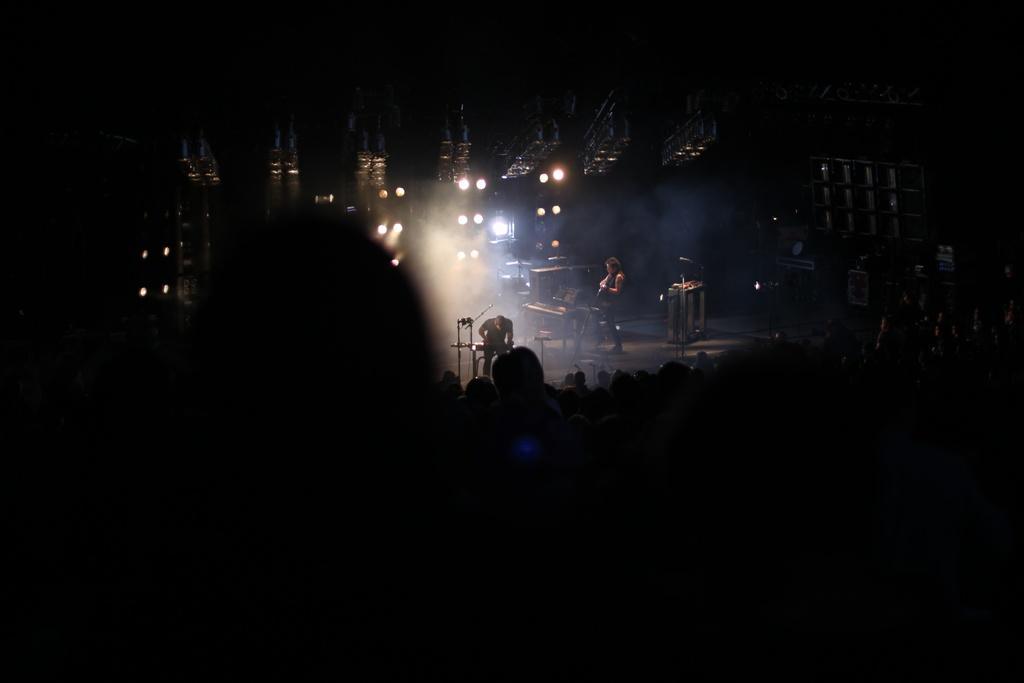Can you describe this image briefly? In this picture there are two persons standing on the stage. There are microphones, musical instruments and devices on the stage. In the foreground there are group of people. At the top there are lights. 